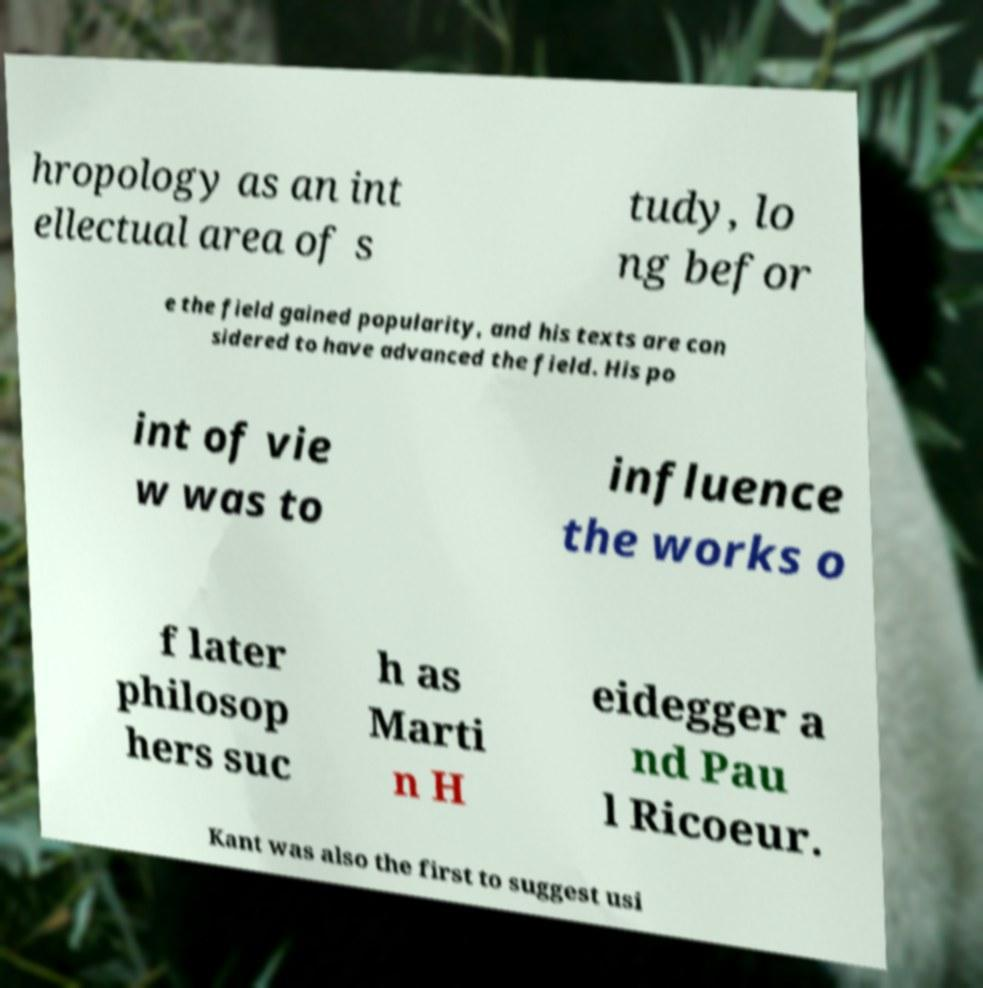Could you extract and type out the text from this image? hropology as an int ellectual area of s tudy, lo ng befor e the field gained popularity, and his texts are con sidered to have advanced the field. His po int of vie w was to influence the works o f later philosop hers suc h as Marti n H eidegger a nd Pau l Ricoeur. Kant was also the first to suggest usi 